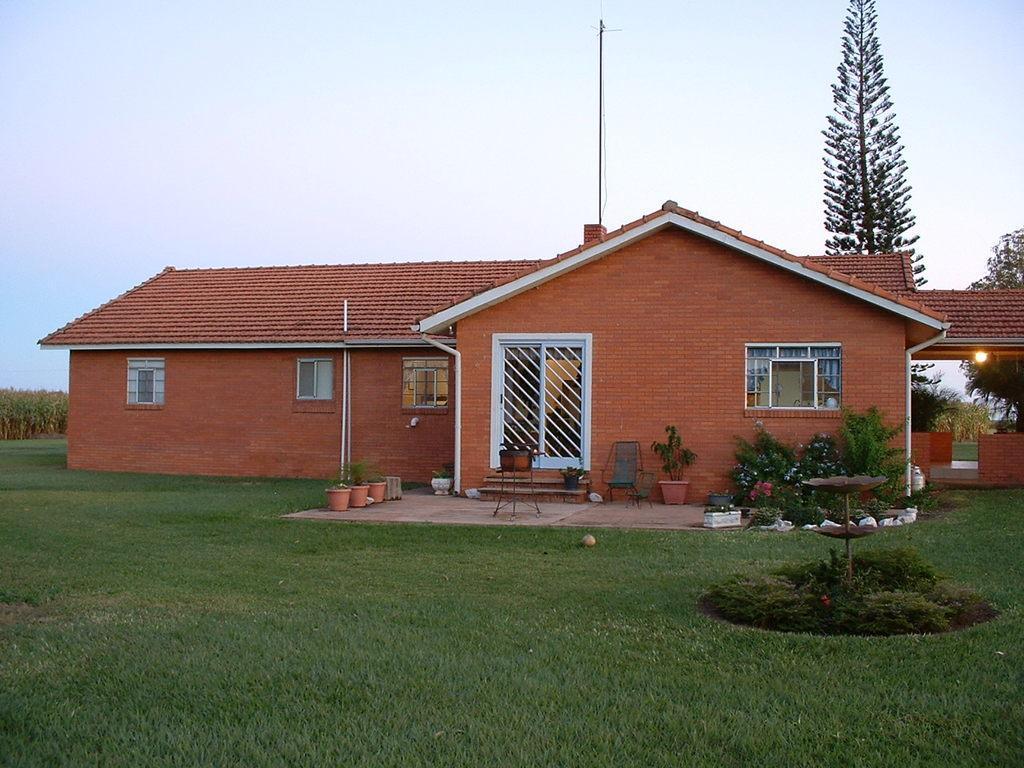Describe this image in one or two sentences. In this image in the front there's grass on the ground. In the center there is a stand which is brown in colour. In the background there is a house and there are plants in the pot, there is an empty chair, there are flowers, there are trees, there is a light and there are windows and there is a door. 